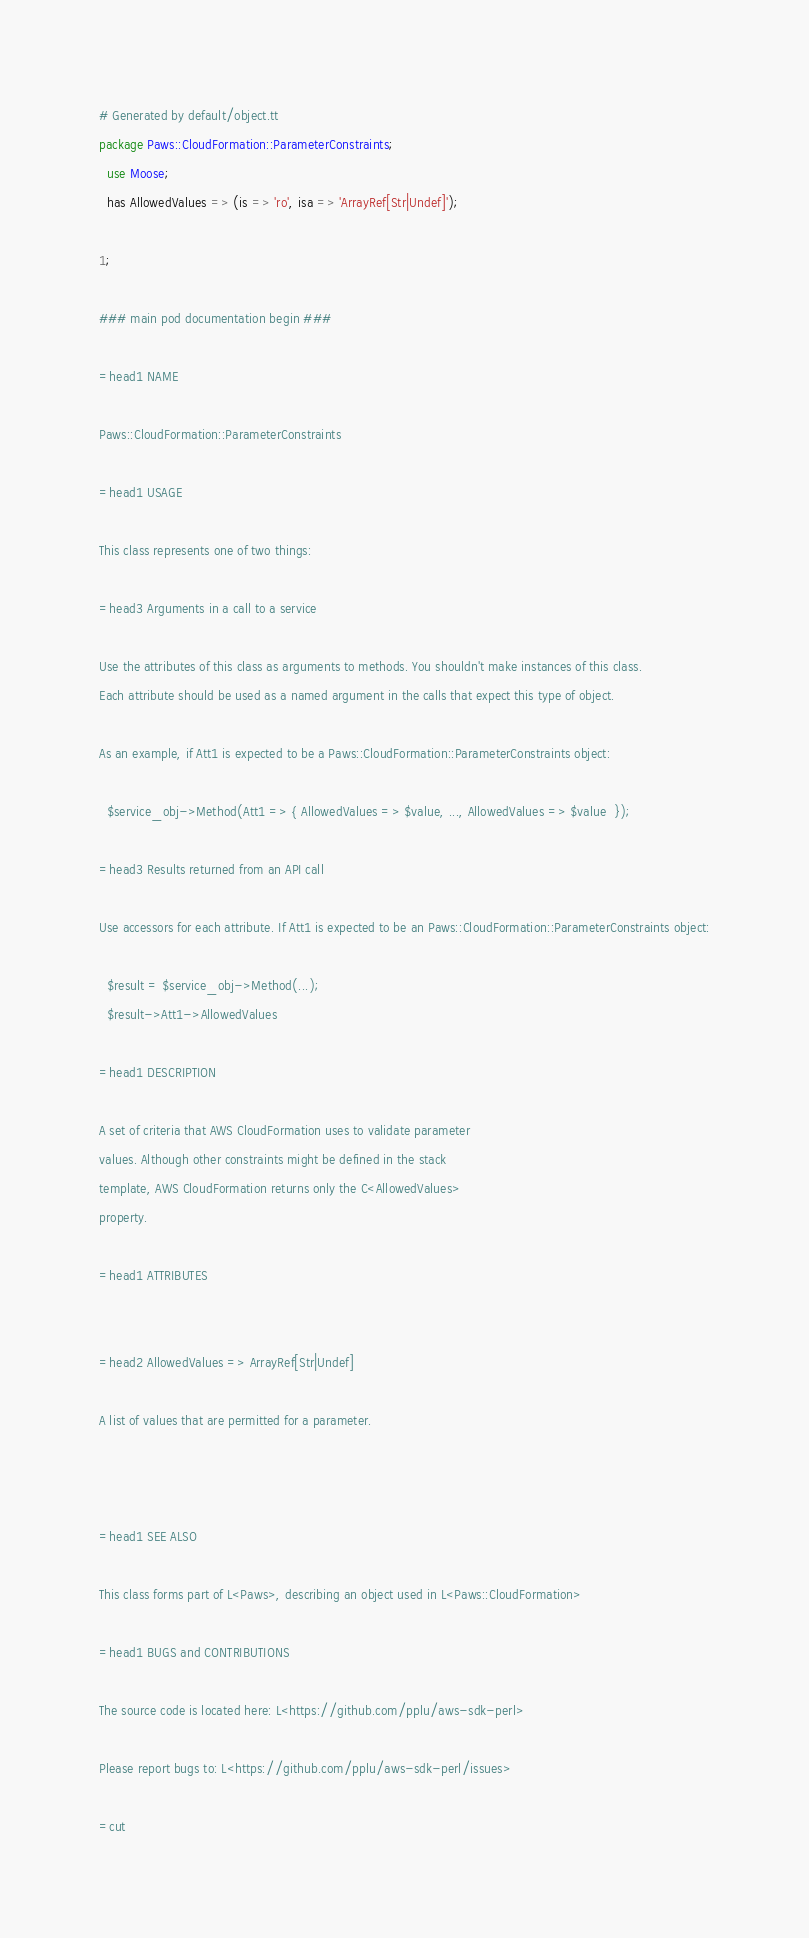Convert code to text. <code><loc_0><loc_0><loc_500><loc_500><_Perl_># Generated by default/object.tt
package Paws::CloudFormation::ParameterConstraints;
  use Moose;
  has AllowedValues => (is => 'ro', isa => 'ArrayRef[Str|Undef]');

1;

### main pod documentation begin ###

=head1 NAME

Paws::CloudFormation::ParameterConstraints

=head1 USAGE

This class represents one of two things:

=head3 Arguments in a call to a service

Use the attributes of this class as arguments to methods. You shouldn't make instances of this class. 
Each attribute should be used as a named argument in the calls that expect this type of object.

As an example, if Att1 is expected to be a Paws::CloudFormation::ParameterConstraints object:

  $service_obj->Method(Att1 => { AllowedValues => $value, ..., AllowedValues => $value  });

=head3 Results returned from an API call

Use accessors for each attribute. If Att1 is expected to be an Paws::CloudFormation::ParameterConstraints object:

  $result = $service_obj->Method(...);
  $result->Att1->AllowedValues

=head1 DESCRIPTION

A set of criteria that AWS CloudFormation uses to validate parameter
values. Although other constraints might be defined in the stack
template, AWS CloudFormation returns only the C<AllowedValues>
property.

=head1 ATTRIBUTES


=head2 AllowedValues => ArrayRef[Str|Undef]

A list of values that are permitted for a parameter.



=head1 SEE ALSO

This class forms part of L<Paws>, describing an object used in L<Paws::CloudFormation>

=head1 BUGS and CONTRIBUTIONS

The source code is located here: L<https://github.com/pplu/aws-sdk-perl>

Please report bugs to: L<https://github.com/pplu/aws-sdk-perl/issues>

=cut

</code> 